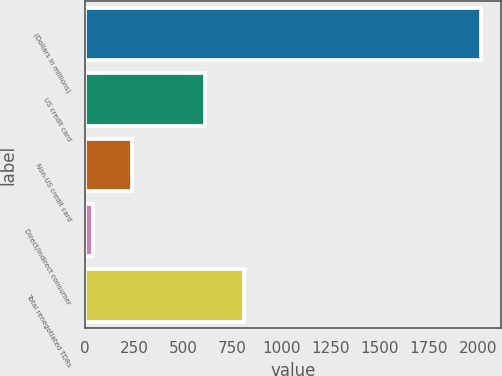Convert chart. <chart><loc_0><loc_0><loc_500><loc_500><bar_chart><fcel>(Dollars in millions)<fcel>US credit card<fcel>Non-US credit card<fcel>Direct/Indirect consumer<fcel>Total renegotiated TDRs<nl><fcel>2015<fcel>611<fcel>239.3<fcel>42<fcel>808.3<nl></chart> 